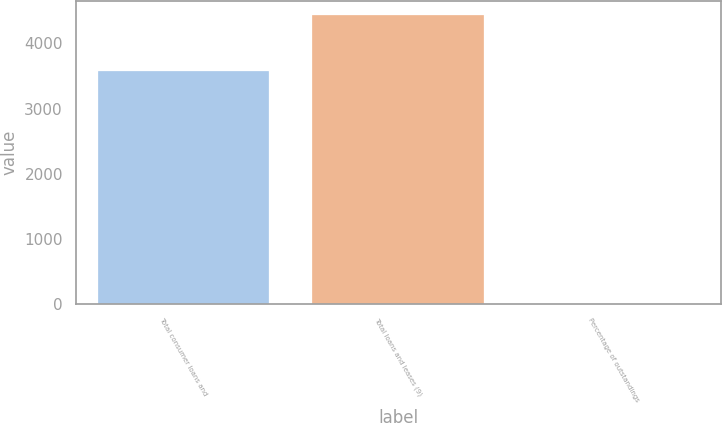<chart> <loc_0><loc_0><loc_500><loc_500><bar_chart><fcel>Total consumer loans and<fcel>Total loans and leases (9)<fcel>Percentage of outstandings<nl><fcel>3581<fcel>4433<fcel>0.48<nl></chart> 